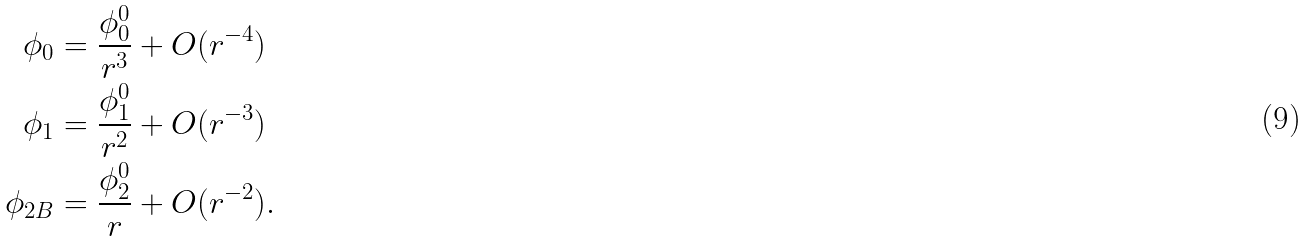Convert formula to latex. <formula><loc_0><loc_0><loc_500><loc_500>\phi _ { 0 } & = \frac { \phi _ { 0 } ^ { 0 } } { r ^ { 3 } } + O ( r ^ { - 4 } ) \\ \phi _ { 1 } & = \frac { \phi _ { 1 } ^ { 0 } } { r ^ { 2 } } + O ( r ^ { - 3 } ) \\ \phi _ { 2 B } & = \frac { \phi _ { 2 } ^ { 0 } } { r } + O ( r ^ { - 2 } ) .</formula> 